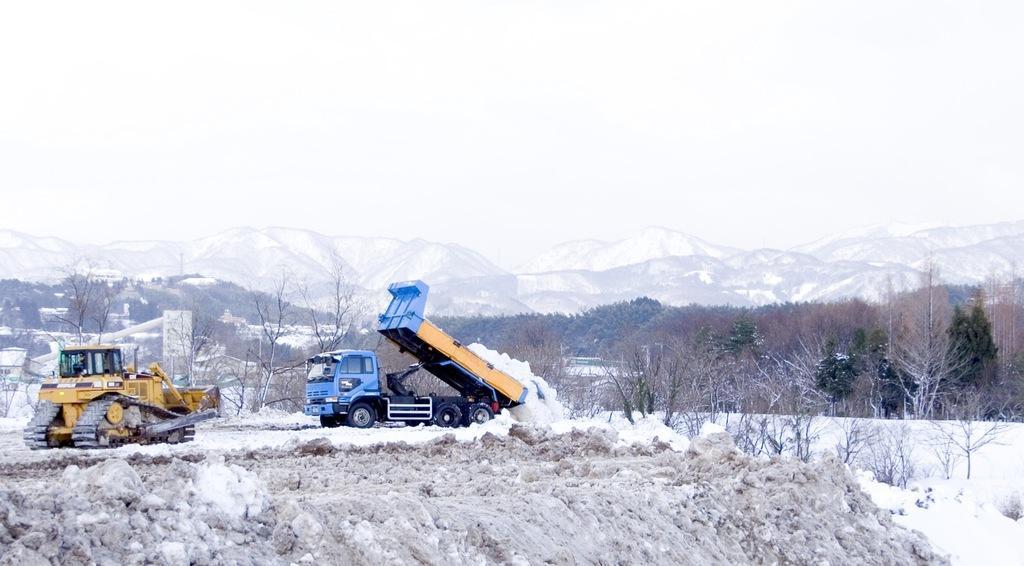How would you summarize this image in a sentence or two? This is an outside view. At the bottom, I can see the snow. On the left side there is a bulldozer and a truck. In the background there are many trees and buildings and also I can see the mountains. At the top of the image I can see the sky. 